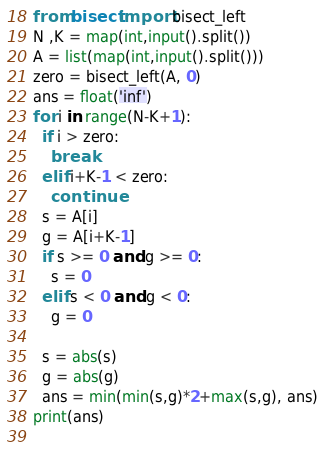<code> <loc_0><loc_0><loc_500><loc_500><_Python_>from bisect import bisect_left
N ,K = map(int,input().split())
A = list(map(int,input().split()))
zero = bisect_left(A, 0)
ans = float('inf')
for i in range(N-K+1):
  if i > zero:
    break
  elif i+K-1 < zero:
    continue
  s = A[i]
  g = A[i+K-1]
  if s >= 0 and g >= 0:
    s = 0
  elif s < 0 and g < 0:
    g = 0

  s = abs(s)
  g = abs(g)
  ans = min(min(s,g)*2+max(s,g), ans)
print(ans)
  </code> 